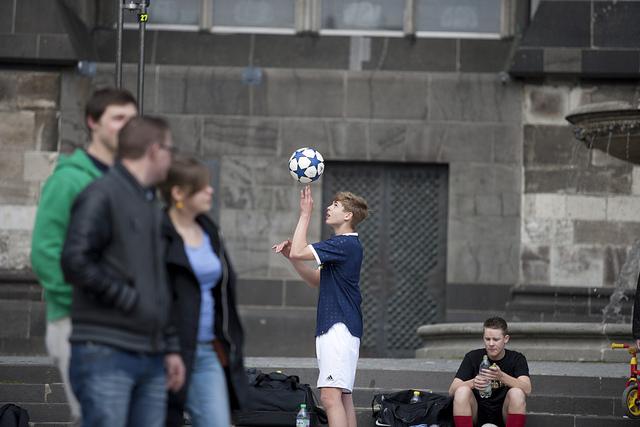Is there a child nearby?
Give a very brief answer. Yes. Is the man in green shirt on a cell phone?
Quick response, please. No. What is the boy on the left holding?
Be succinct. Soccer ball. What blue shapes are on the soccer ball in the photo?
Short answer required. Stars. Is the kid with the soccer ball talented?
Short answer required. Yes. 